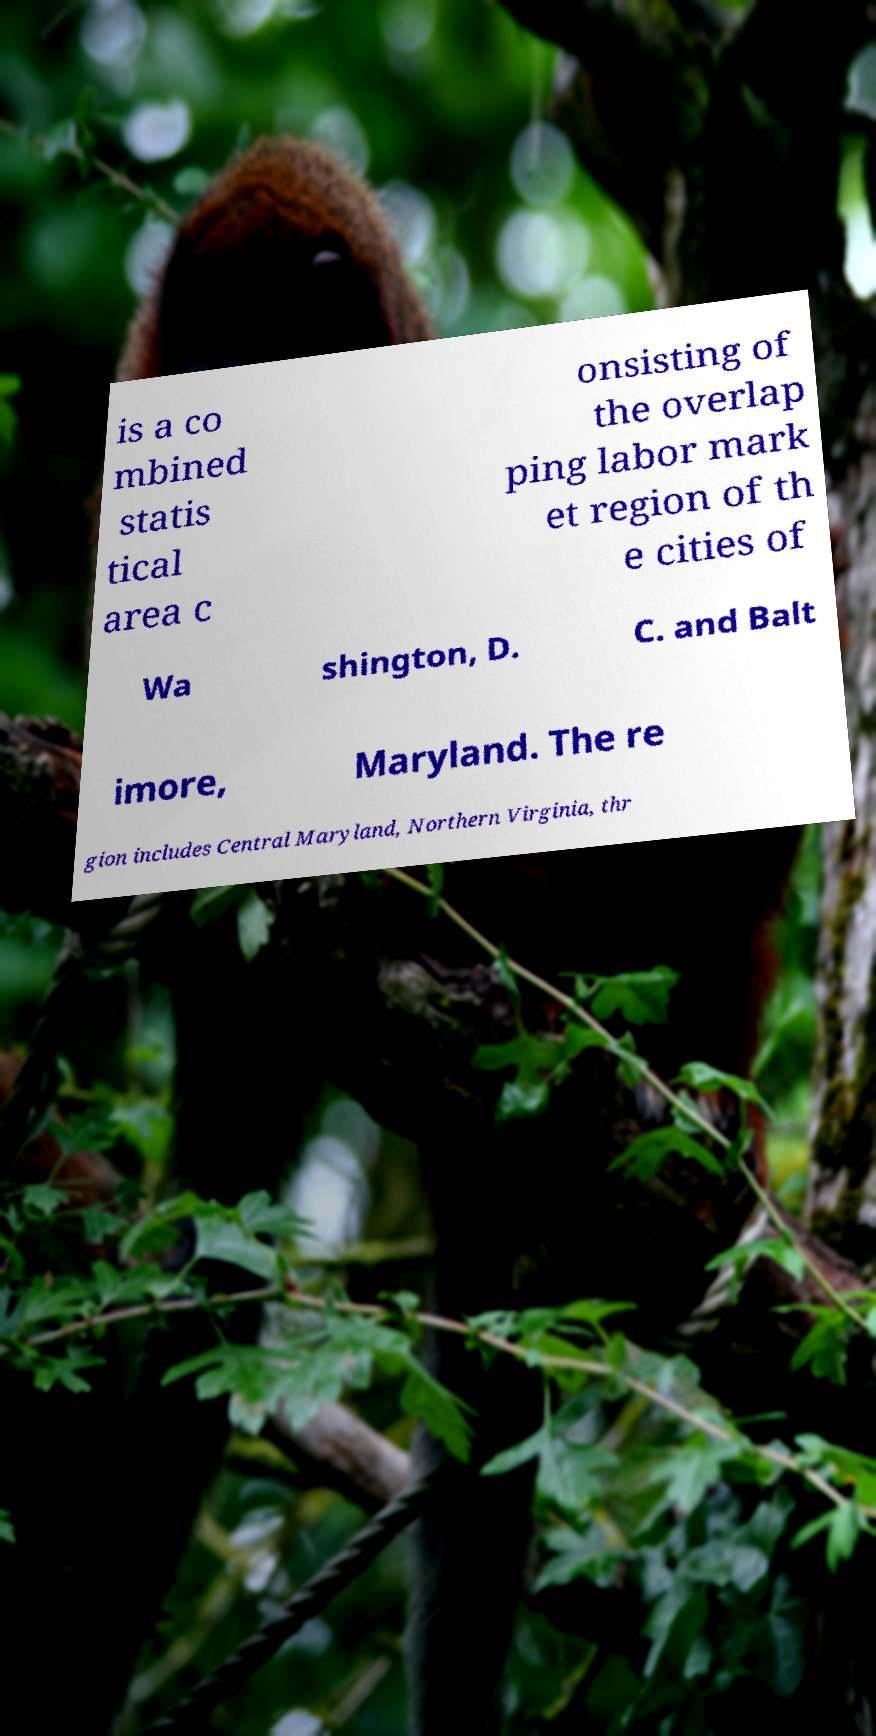Please read and relay the text visible in this image. What does it say? is a co mbined statis tical area c onsisting of the overlap ping labor mark et region of th e cities of Wa shington, D. C. and Balt imore, Maryland. The re gion includes Central Maryland, Northern Virginia, thr 